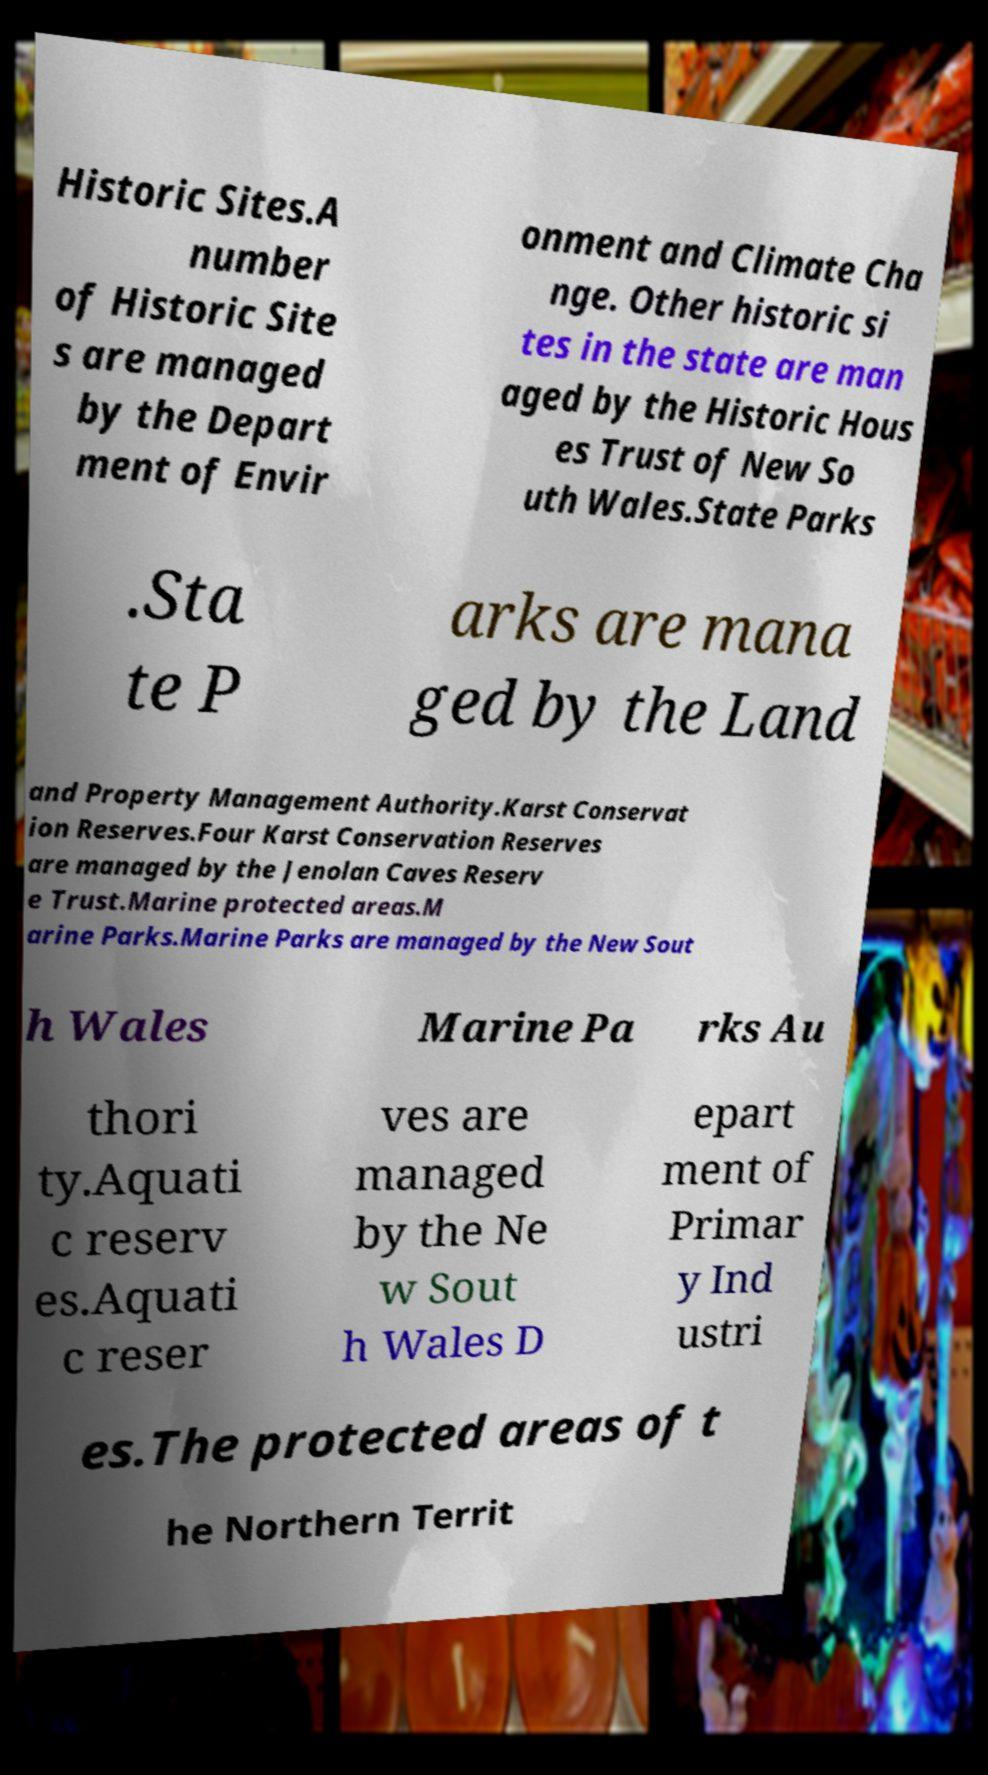There's text embedded in this image that I need extracted. Can you transcribe it verbatim? Historic Sites.A number of Historic Site s are managed by the Depart ment of Envir onment and Climate Cha nge. Other historic si tes in the state are man aged by the Historic Hous es Trust of New So uth Wales.State Parks .Sta te P arks are mana ged by the Land and Property Management Authority.Karst Conservat ion Reserves.Four Karst Conservation Reserves are managed by the Jenolan Caves Reserv e Trust.Marine protected areas.M arine Parks.Marine Parks are managed by the New Sout h Wales Marine Pa rks Au thori ty.Aquati c reserv es.Aquati c reser ves are managed by the Ne w Sout h Wales D epart ment of Primar y Ind ustri es.The protected areas of t he Northern Territ 